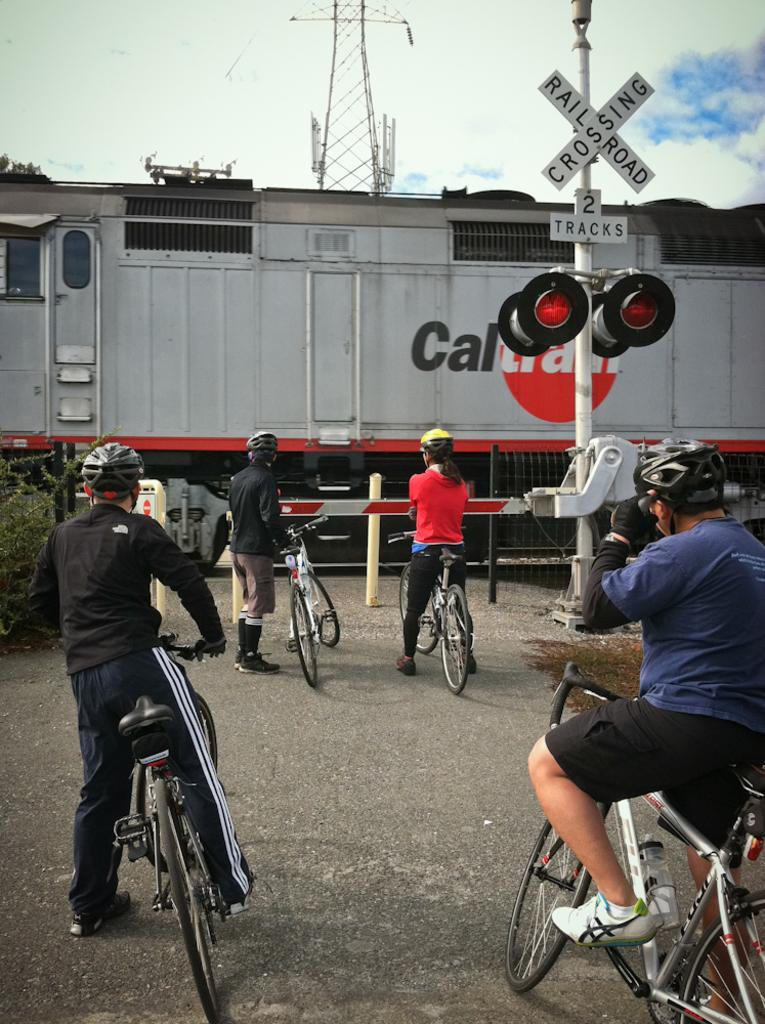How many people are standing on the road in the image? There are 4 people standing on the road in the image. What are the people holding or standing near? The people have bicycles. What else can be seen in the image besides the people and bicycles? There is: There is a train and a train signal in the image. Is there any indication of a controlled crossing in the image? Yes, there is a gate in the image, which suggests a controlled crossing. What type of pickle is being used as a decoration on the train in the image? There is no pickle present in the image, as it features people with bicycles, a train, a train signal, and a gate. 